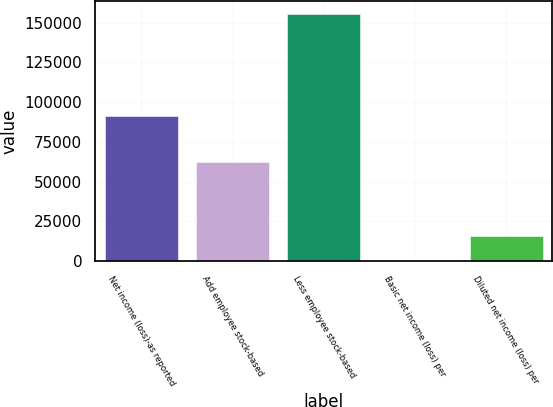Convert chart. <chart><loc_0><loc_0><loc_500><loc_500><bar_chart><fcel>Net income (loss)-as reported<fcel>Add employee stock-based<fcel>Less employee stock-based<fcel>Basic net income (loss) per<fcel>Diluted net income (loss) per<nl><fcel>91156<fcel>62207.7<fcel>155519<fcel>0.18<fcel>15552.1<nl></chart> 